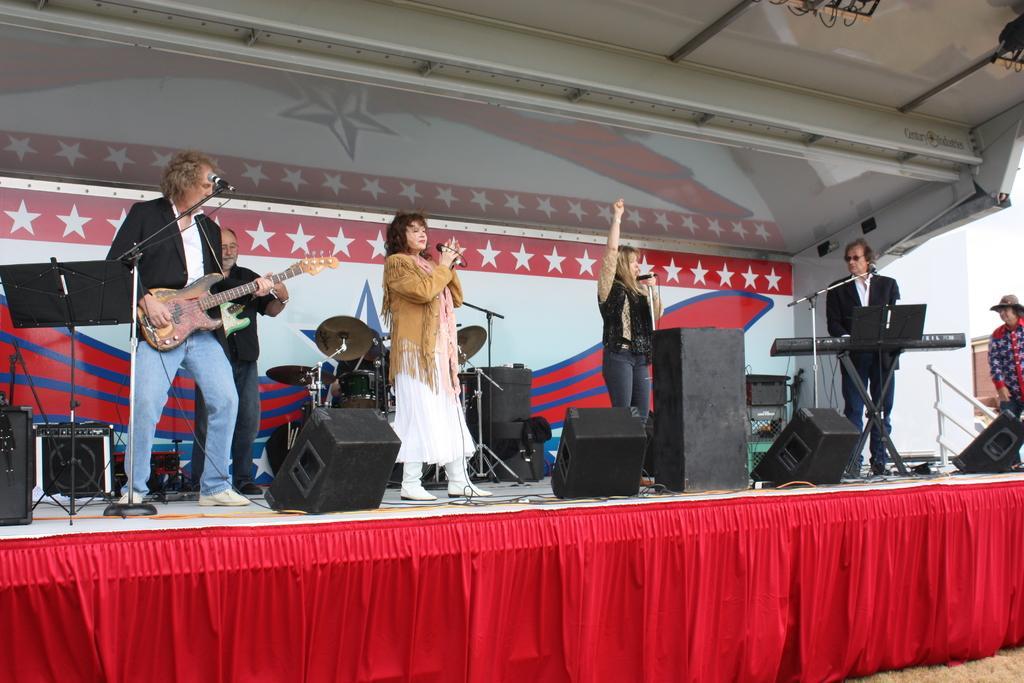In one or two sentences, can you explain what this image depicts? In this image we can see few people standing on the stage. The man on the left side of the image is playing the guitar. The man on the right side of the image is playing piano. This is the electronic drums. 